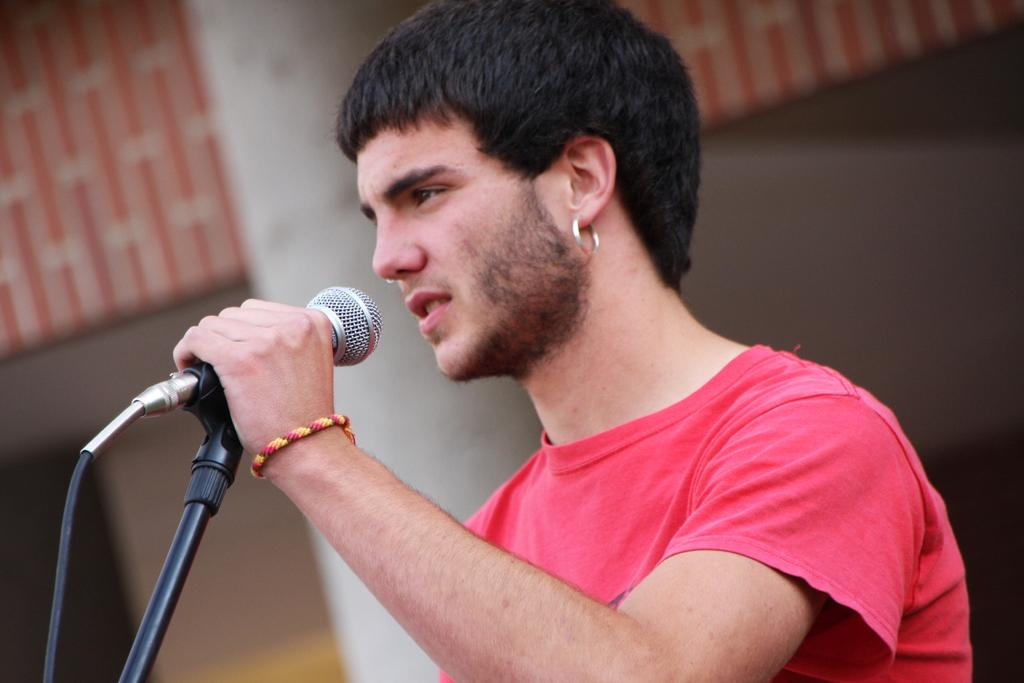What is the main subject of the image? There is a man in the image. What is the man holding in the image? The man is holding a mic. Where is the stove located in the image? There is no stove present in the image. What type of kitty can be seen sitting on the cushion in the image? There is no kitty or cushion present in the image. 